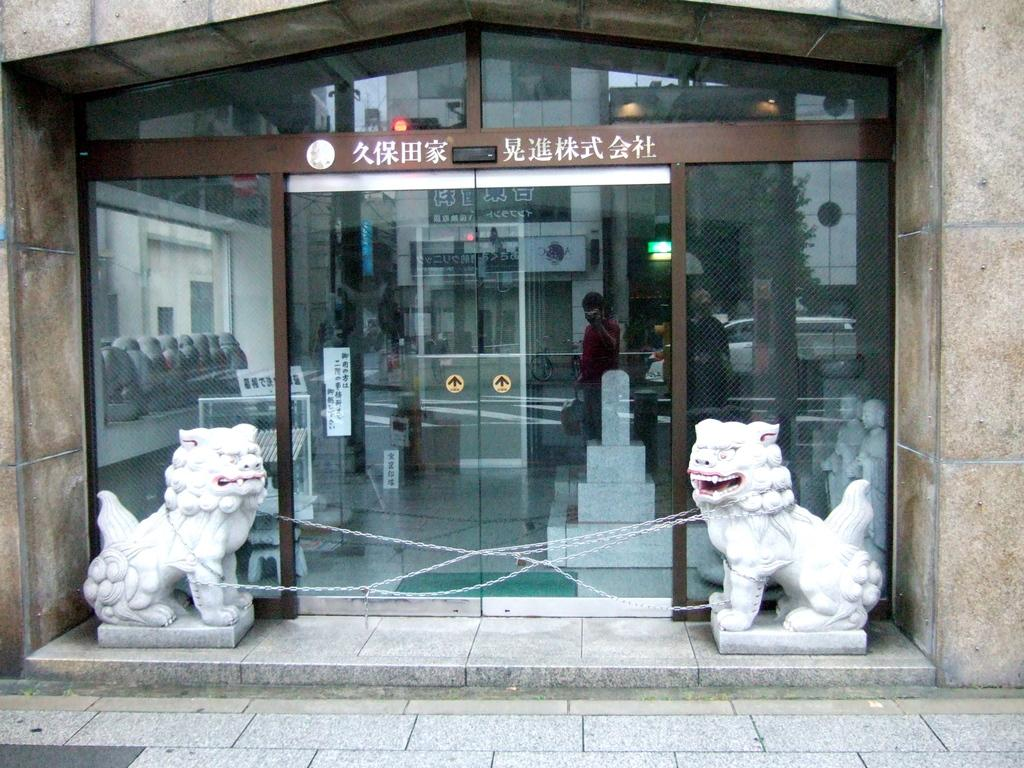What type of objects are the white color statues in the image? The white color statues in the image are of animals. What is the other object visible in the image? There is a glass in the image. What can be seen inside the glass? Few people, a building, and trees are visible inside the glass. What type of chalk is being used to draw on the statues in the image? There is no chalk or drawing activity visible in the image; the statues are white color and stationary. 